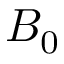<formula> <loc_0><loc_0><loc_500><loc_500>B _ { 0 }</formula> 